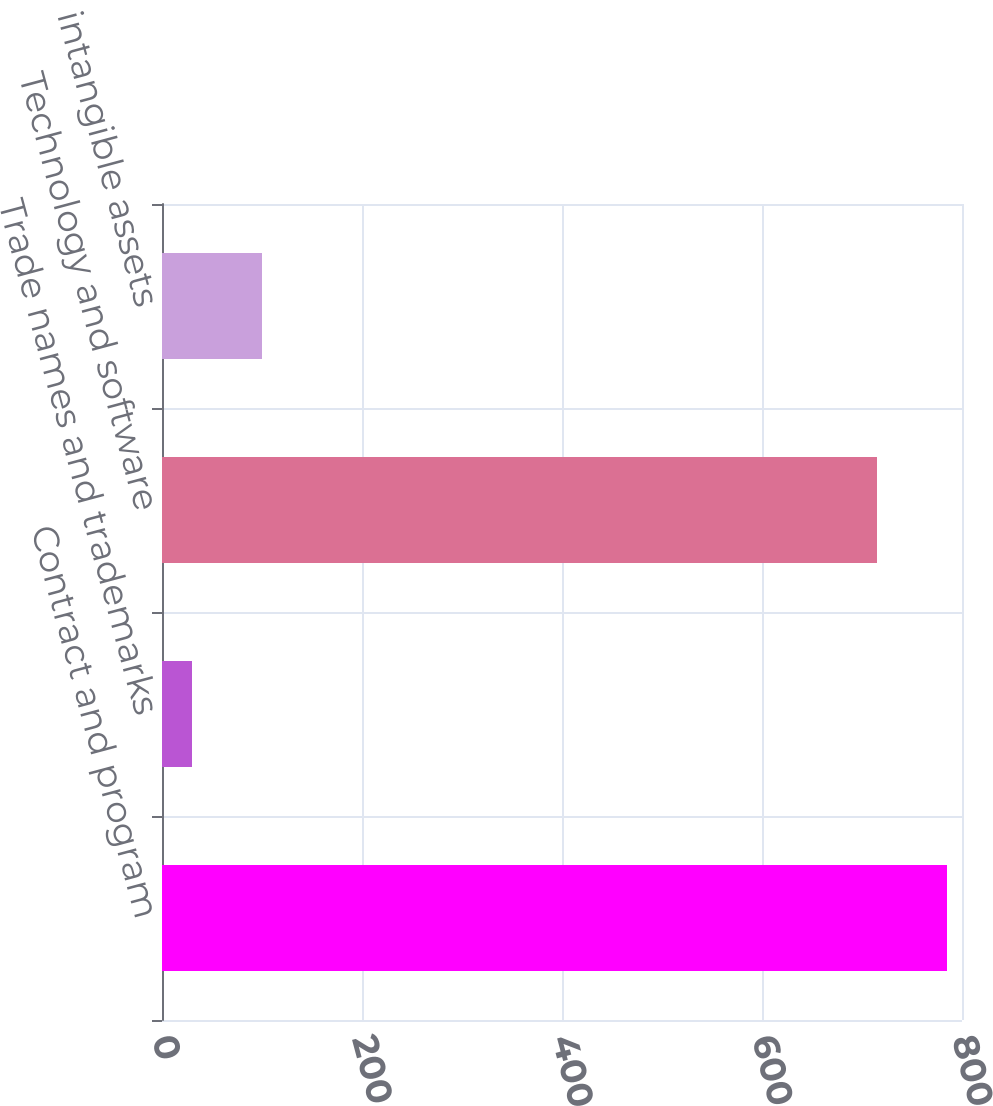Convert chart to OTSL. <chart><loc_0><loc_0><loc_500><loc_500><bar_chart><fcel>Contract and program<fcel>Trade names and trademarks<fcel>Technology and software<fcel>Other intangible assets<nl><fcel>785<fcel>30<fcel>715<fcel>100<nl></chart> 